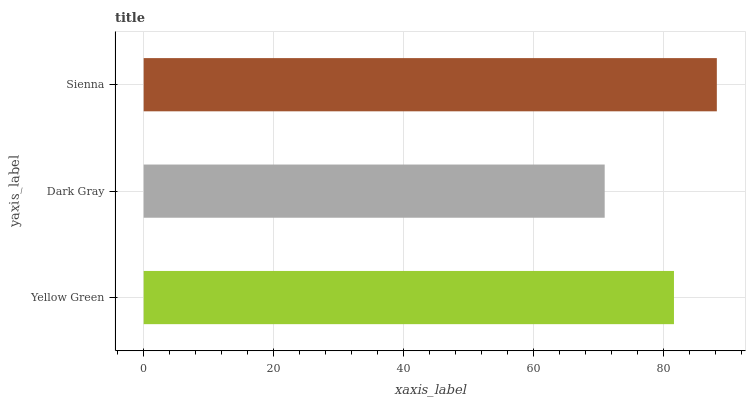Is Dark Gray the minimum?
Answer yes or no. Yes. Is Sienna the maximum?
Answer yes or no. Yes. Is Sienna the minimum?
Answer yes or no. No. Is Dark Gray the maximum?
Answer yes or no. No. Is Sienna greater than Dark Gray?
Answer yes or no. Yes. Is Dark Gray less than Sienna?
Answer yes or no. Yes. Is Dark Gray greater than Sienna?
Answer yes or no. No. Is Sienna less than Dark Gray?
Answer yes or no. No. Is Yellow Green the high median?
Answer yes or no. Yes. Is Yellow Green the low median?
Answer yes or no. Yes. Is Dark Gray the high median?
Answer yes or no. No. Is Dark Gray the low median?
Answer yes or no. No. 